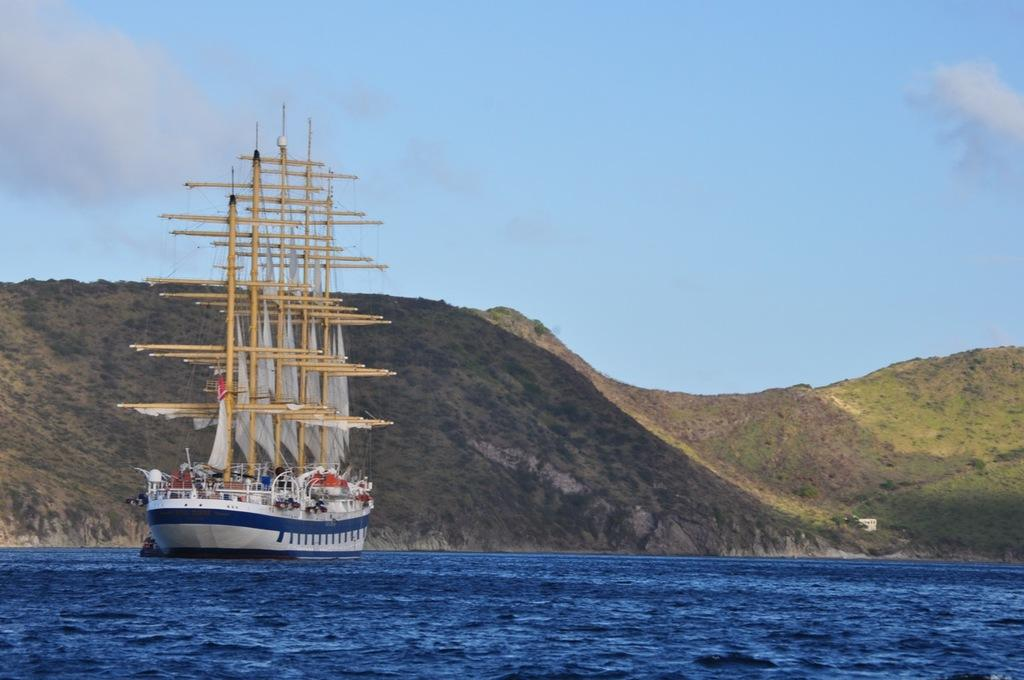What is at the bottom of the image? There is water at the bottom of the image. What can be seen on the left side of the image? There is a ship on the left side of the image. What type of vegetation is visible in the background of the image? There is grass visible in the background of the image. What geographical feature is present in the background of the image? There is a hill in the background of the image. What is visible at the top of the image? The sky is visible at the top of the image. How much money is being exchanged between the ship and the hill in the image? There is no exchange of money depicted in the image; it features a ship, water, grass, a hill, and the sky. What care is being provided to the grass in the image? There is no indication of care being provided to the grass in the image; it is simply visible in the background. 